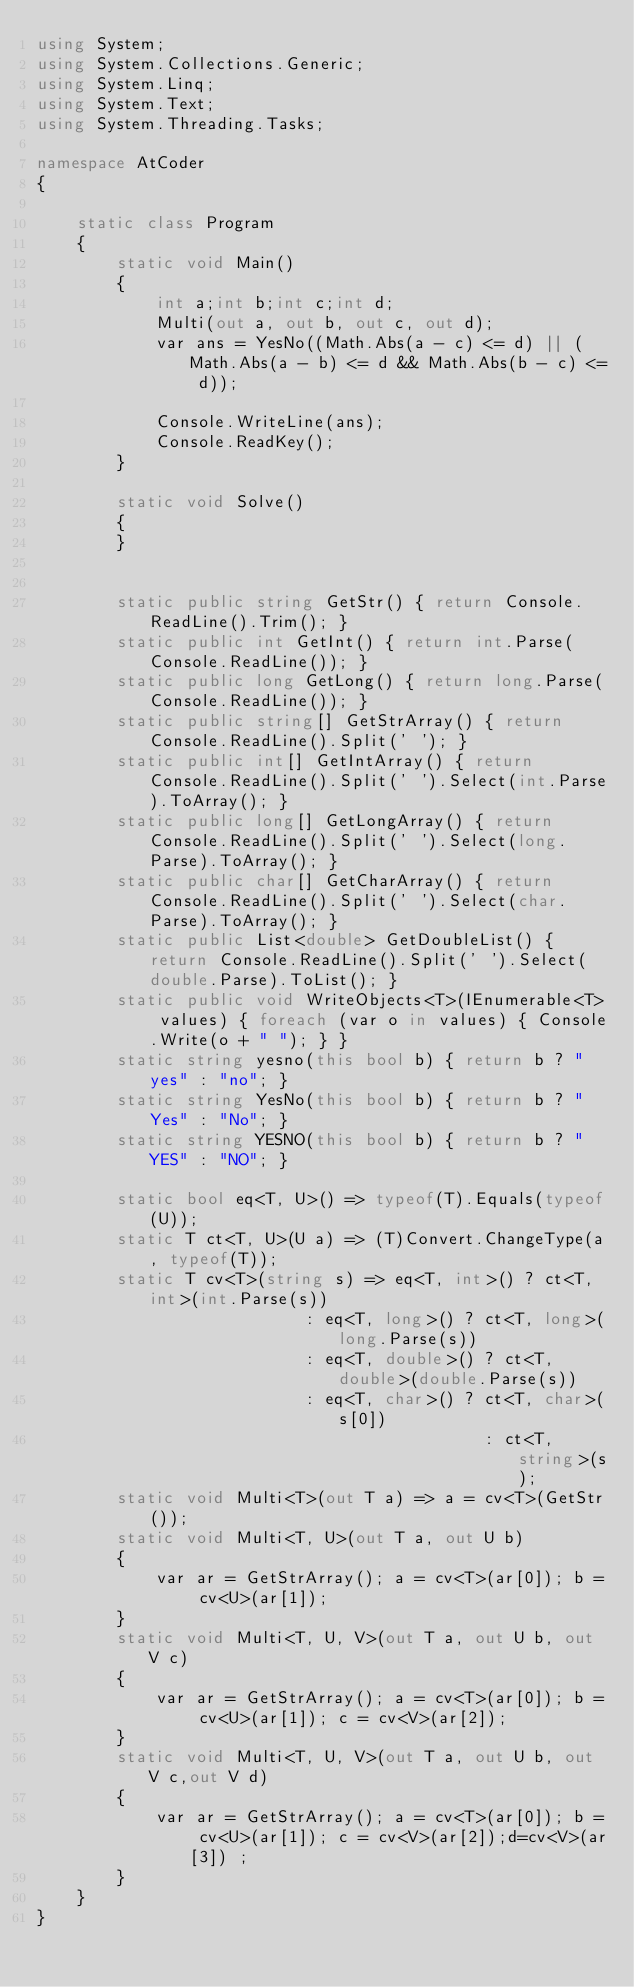Convert code to text. <code><loc_0><loc_0><loc_500><loc_500><_C#_>using System;
using System.Collections.Generic;
using System.Linq;
using System.Text;
using System.Threading.Tasks;

namespace AtCoder
{

    static class Program
    {
        static void Main()
        {
            int a;int b;int c;int d;
            Multi(out a, out b, out c, out d);
            var ans = YesNo((Math.Abs(a - c) <= d) || (Math.Abs(a - b) <= d && Math.Abs(b - c) <= d));

            Console.WriteLine(ans);
            Console.ReadKey();
        }

        static void Solve()
        {
        }


        static public string GetStr() { return Console.ReadLine().Trim(); }
        static public int GetInt() { return int.Parse(Console.ReadLine()); }
        static public long GetLong() { return long.Parse(Console.ReadLine()); }
        static public string[] GetStrArray() { return Console.ReadLine().Split(' '); }
        static public int[] GetIntArray() { return Console.ReadLine().Split(' ').Select(int.Parse).ToArray(); }
        static public long[] GetLongArray() { return Console.ReadLine().Split(' ').Select(long.Parse).ToArray(); }
        static public char[] GetCharArray() { return Console.ReadLine().Split(' ').Select(char.Parse).ToArray(); }
        static public List<double> GetDoubleList() { return Console.ReadLine().Split(' ').Select(double.Parse).ToList(); }
        static public void WriteObjects<T>(IEnumerable<T> values) { foreach (var o in values) { Console.Write(o + " "); } }
        static string yesno(this bool b) { return b ? "yes" : "no"; }
        static string YesNo(this bool b) { return b ? "Yes" : "No"; }
        static string YESNO(this bool b) { return b ? "YES" : "NO"; }

        static bool eq<T, U>() => typeof(T).Equals(typeof(U));
        static T ct<T, U>(U a) => (T)Convert.ChangeType(a, typeof(T));
        static T cv<T>(string s) => eq<T, int>() ? ct<T, int>(int.Parse(s))
                           : eq<T, long>() ? ct<T, long>(long.Parse(s))
                           : eq<T, double>() ? ct<T, double>(double.Parse(s))
                           : eq<T, char>() ? ct<T, char>(s[0])
                                             : ct<T, string>(s);
        static void Multi<T>(out T a) => a = cv<T>(GetStr());
        static void Multi<T, U>(out T a, out U b)
        {
            var ar = GetStrArray(); a = cv<T>(ar[0]); b = cv<U>(ar[1]);
        }
        static void Multi<T, U, V>(out T a, out U b, out V c)
        {
            var ar = GetStrArray(); a = cv<T>(ar[0]); b = cv<U>(ar[1]); c = cv<V>(ar[2]);
        }
        static void Multi<T, U, V>(out T a, out U b, out V c,out V d)
        {
            var ar = GetStrArray(); a = cv<T>(ar[0]); b = cv<U>(ar[1]); c = cv<V>(ar[2]);d=cv<V>(ar[3]) ;
        }
    }
}</code> 